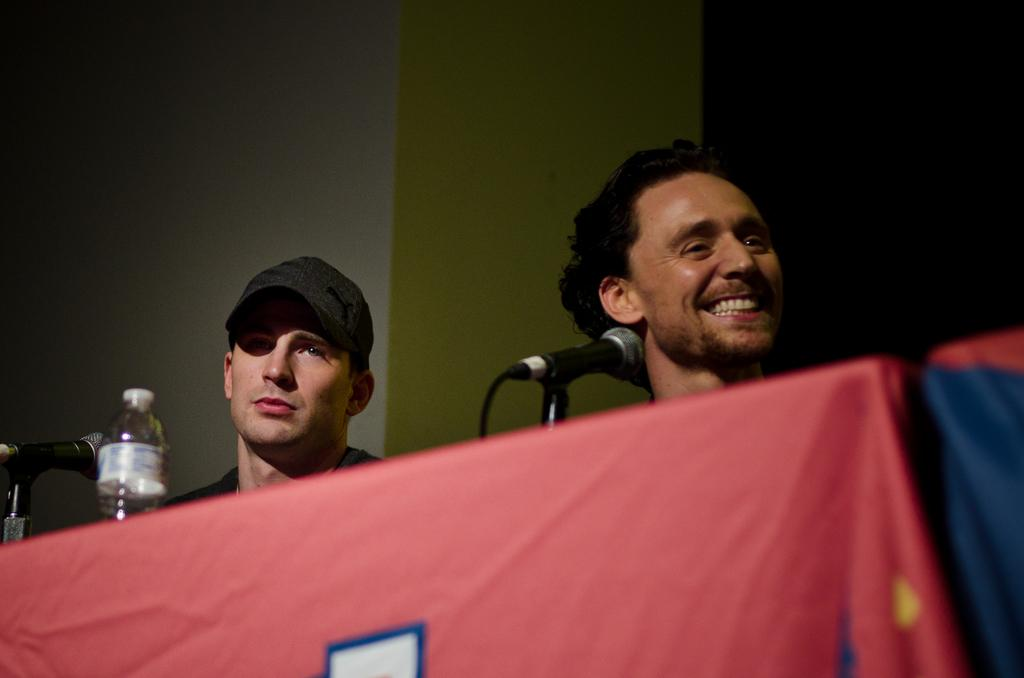How many people are in the image? There are persons in the image, but the exact number is not specified. What is on the table in the image? There is a cloth, a bottle, and a microphone (mike) on the table. What can be seen in the background of the image? There is a wall in the background of the image. What color are the beads on the feet of the person in the image? There are no beads or feet mentioned in the image, so it is not possible to answer that question. 